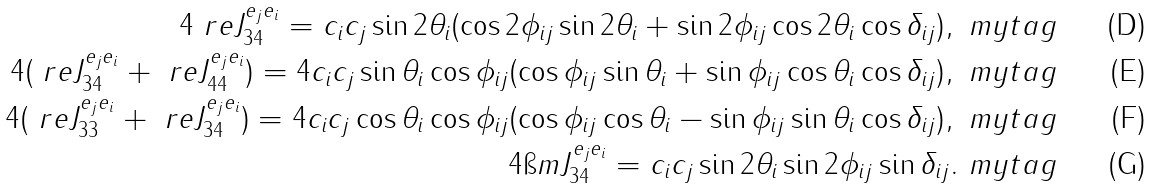<formula> <loc_0><loc_0><loc_500><loc_500>4 \ r e J ^ { e _ { j } e _ { i } } _ { 3 4 } = c _ { i } c _ { j } \sin 2 \theta _ { i } ( \cos 2 \phi _ { i j } \sin 2 \theta _ { i } + \sin 2 \phi _ { i j } \cos 2 \theta _ { i } \cos \delta _ { i j } ) , \ m y t a g \\ 4 ( \ r e J ^ { e _ { j } e _ { i } } _ { 3 4 } + \ r e J ^ { e _ { j } e _ { i } } _ { 4 4 } ) = 4 c _ { i } c _ { j } \sin \theta _ { i } \cos \phi _ { i j } ( \cos \phi _ { i j } \sin \theta _ { i } + \sin \phi _ { i j } \cos \theta _ { i } \cos \delta _ { i j } ) , \ m y t a g \\ 4 ( \ r e J ^ { e _ { j } e _ { i } } _ { 3 3 } + \ r e J ^ { e _ { j } e _ { i } } _ { 3 4 } ) = 4 c _ { i } c _ { j } \cos \theta _ { i } \cos \phi _ { i j } ( \cos \phi _ { i j } \cos \theta _ { i } - \sin \phi _ { i j } \sin \theta _ { i } \cos \delta _ { i j } ) , \ m y t a g \\ 4 \i m J ^ { e _ { j } e _ { i } } _ { 3 4 } = c _ { i } c _ { j } \sin 2 \theta _ { i } \sin 2 \phi _ { i j } \sin \delta _ { i j } . \ m y t a g</formula> 